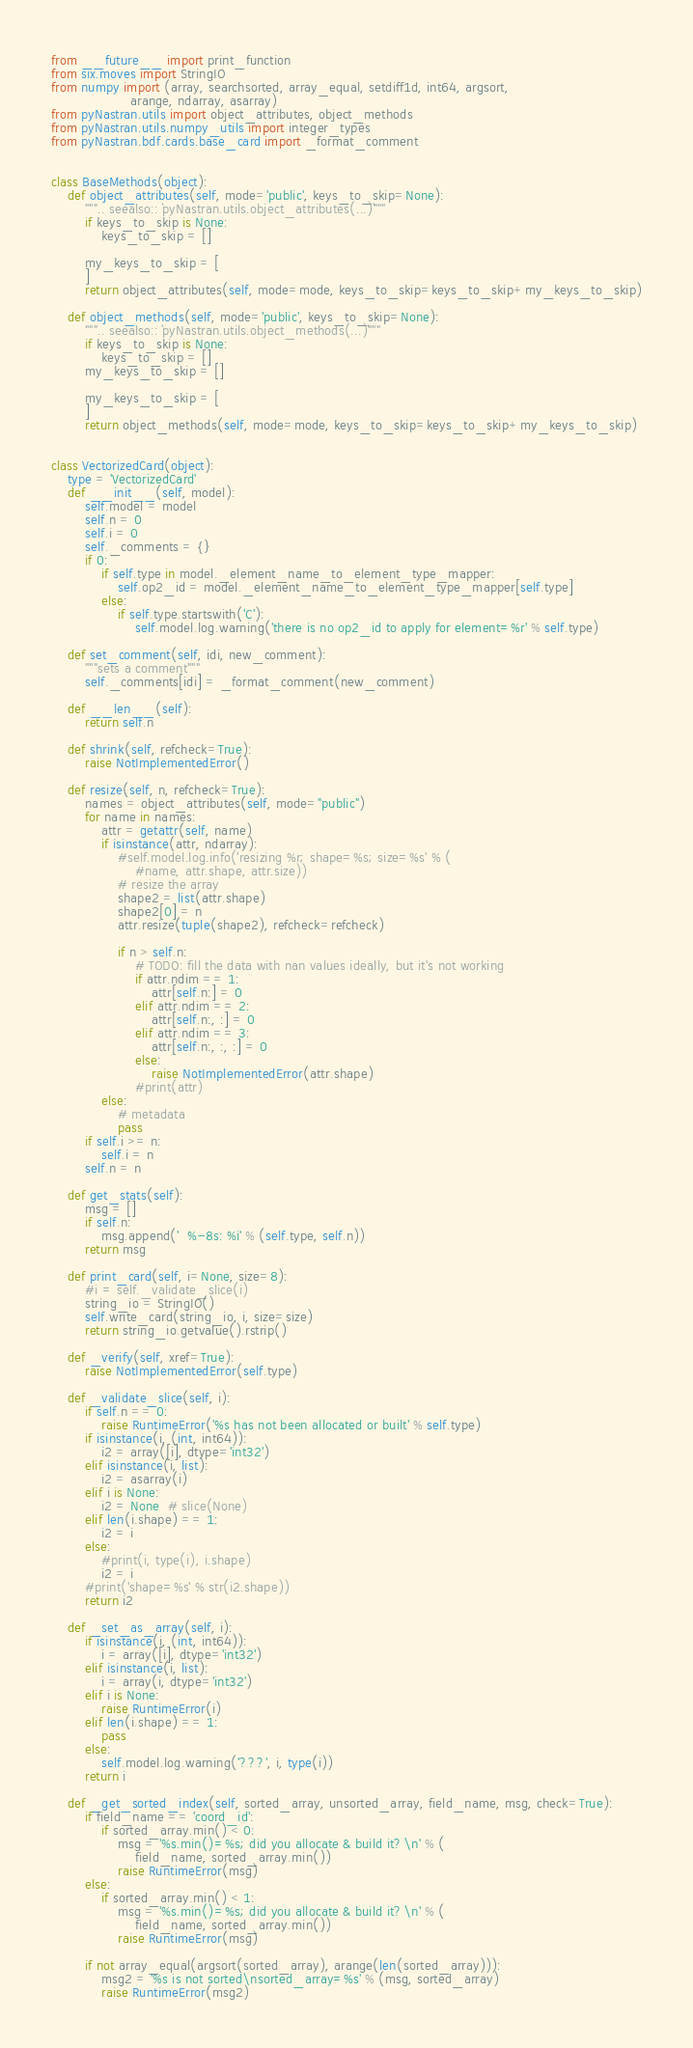Convert code to text. <code><loc_0><loc_0><loc_500><loc_500><_Python_>from __future__ import print_function
from six.moves import StringIO
from numpy import (array, searchsorted, array_equal, setdiff1d, int64, argsort,
                   arange, ndarray, asarray)
from pyNastran.utils import object_attributes, object_methods
from pyNastran.utils.numpy_utils import integer_types
from pyNastran.bdf.cards.base_card import _format_comment


class BaseMethods(object):
    def object_attributes(self, mode='public', keys_to_skip=None):
        """.. seealso:: `pyNastran.utils.object_attributes(...)`"""
        if keys_to_skip is None:
            keys_to_skip = []

        my_keys_to_skip = [
        ]
        return object_attributes(self, mode=mode, keys_to_skip=keys_to_skip+my_keys_to_skip)

    def object_methods(self, mode='public', keys_to_skip=None):
        """.. seealso:: `pyNastran.utils.object_methods(...)`"""
        if keys_to_skip is None:
            keys_to_skip = []
        my_keys_to_skip = []

        my_keys_to_skip = [
        ]
        return object_methods(self, mode=mode, keys_to_skip=keys_to_skip+my_keys_to_skip)


class VectorizedCard(object):
    type = 'VectorizedCard'
    def __init__(self, model):
        self.model = model
        self.n = 0
        self.i = 0
        self._comments = {}
        if 0:
            if self.type in model._element_name_to_element_type_mapper:
                self.op2_id = model._element_name_to_element_type_mapper[self.type]
            else:
                if self.type.startswith('C'):
                    self.model.log.warning('there is no op2_id to apply for element=%r' % self.type)

    def set_comment(self, idi, new_comment):
        """sets a comment"""
        self._comments[idi] = _format_comment(new_comment)

    def __len__(self):
        return self.n

    def shrink(self, refcheck=True):
        raise NotImplementedError()

    def resize(self, n, refcheck=True):
        names = object_attributes(self, mode="public")
        for name in names:
            attr = getattr(self, name)
            if isinstance(attr, ndarray):
                #self.model.log.info('resizing %r; shape=%s; size=%s' % (
                    #name, attr.shape, attr.size))
                # resize the array
                shape2 = list(attr.shape)
                shape2[0] = n
                attr.resize(tuple(shape2), refcheck=refcheck)

                if n > self.n:
                    # TODO: fill the data with nan values ideally, but it's not working
                    if attr.ndim == 1:
                        attr[self.n:] = 0
                    elif attr.ndim == 2:
                        attr[self.n:, :] = 0
                    elif attr.ndim == 3:
                        attr[self.n:, :, :] = 0
                    else:
                        raise NotImplementedError(attr.shape)
                    #print(attr)
            else:
                # metadata
                pass
        if self.i >= n:
            self.i = n
        self.n = n

    def get_stats(self):
        msg = []
        if self.n:
            msg.append('  %-8s: %i' % (self.type, self.n))
        return msg

    def print_card(self, i=None, size=8):
        #i = self._validate_slice(i)
        string_io = StringIO()
        self.write_card(string_io, i, size=size)
        return string_io.getvalue().rstrip()

    def _verify(self, xref=True):
        raise NotImplementedError(self.type)

    def _validate_slice(self, i):
        if self.n == 0:
            raise RuntimeError('%s has not been allocated or built' % self.type)
        if isinstance(i, (int, int64)):
            i2 = array([i], dtype='int32')
        elif isinstance(i, list):
            i2 = asarray(i)
        elif i is None:
            i2 = None  # slice(None)
        elif len(i.shape) == 1:
            i2 = i
        else:
            #print(i, type(i), i.shape)
            i2 = i
        #print('shape=%s' % str(i2.shape))
        return i2

    def _set_as_array(self, i):
        if isinstance(i, (int, int64)):
            i = array([i], dtype='int32')
        elif isinstance(i, list):
            i = array(i, dtype='int32')
        elif i is None:
            raise RuntimeError(i)
        elif len(i.shape) == 1:
            pass
        else:
            self.model.log.warning('???', i, type(i))
        return i

    def _get_sorted_index(self, sorted_array, unsorted_array, field_name, msg, check=True):
        if field_name == 'coord_id':
            if sorted_array.min() < 0:
                msg = '%s.min()=%s; did you allocate & build it?\n' % (
                    field_name, sorted_array.min())
                raise RuntimeError(msg)
        else:
            if sorted_array.min() < 1:
                msg = '%s.min()=%s; did you allocate & build it?\n' % (
                    field_name, sorted_array.min())
                raise RuntimeError(msg)

        if not array_equal(argsort(sorted_array), arange(len(sorted_array))):
            msg2 = '%s is not sorted\nsorted_array=%s' % (msg, sorted_array)
            raise RuntimeError(msg2)</code> 